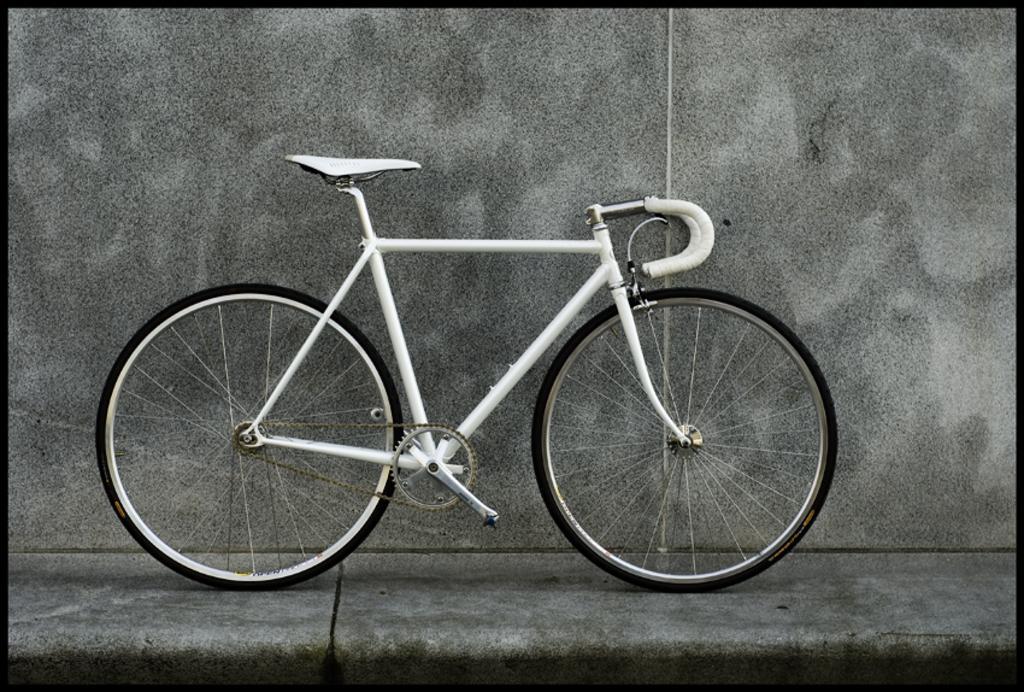Could you give a brief overview of what you see in this image? In the center of the picture there is a bicycle on the footpath. In the background it is well. 